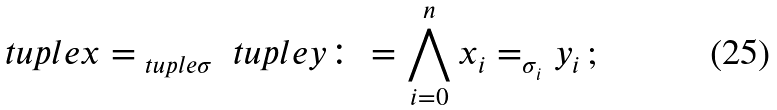Convert formula to latex. <formula><loc_0><loc_0><loc_500><loc_500>\ t u p l e { x } = _ { \ t u p l e { \sigma } } \ t u p l e { y } \colon = \bigwedge _ { i = 0 } ^ { n } x _ { i } = _ { \sigma _ { i } } y _ { i } \, ;</formula> 